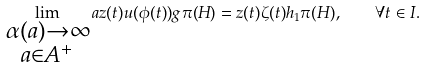Convert formula to latex. <formula><loc_0><loc_0><loc_500><loc_500>\lim _ { \substack { \alpha ( a ) \to \infty \\ a \in A ^ { + } } } a z ( t ) u ( \phi ( t ) ) g \pi ( H ) = z ( t ) \zeta ( t ) h _ { 1 } \pi ( H ) , \quad \forall t \in I .</formula> 